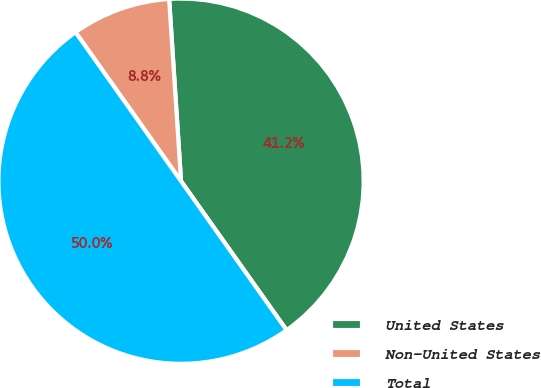Convert chart. <chart><loc_0><loc_0><loc_500><loc_500><pie_chart><fcel>United States<fcel>Non-United States<fcel>Total<nl><fcel>41.23%<fcel>8.77%<fcel>50.0%<nl></chart> 